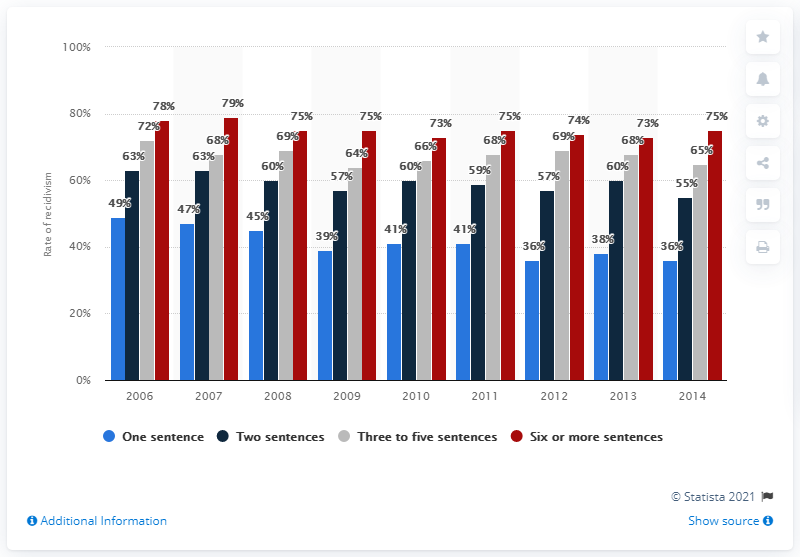Identify some key points in this picture. The rate of recidivism among prisoners with one previous sentence was 36%. 